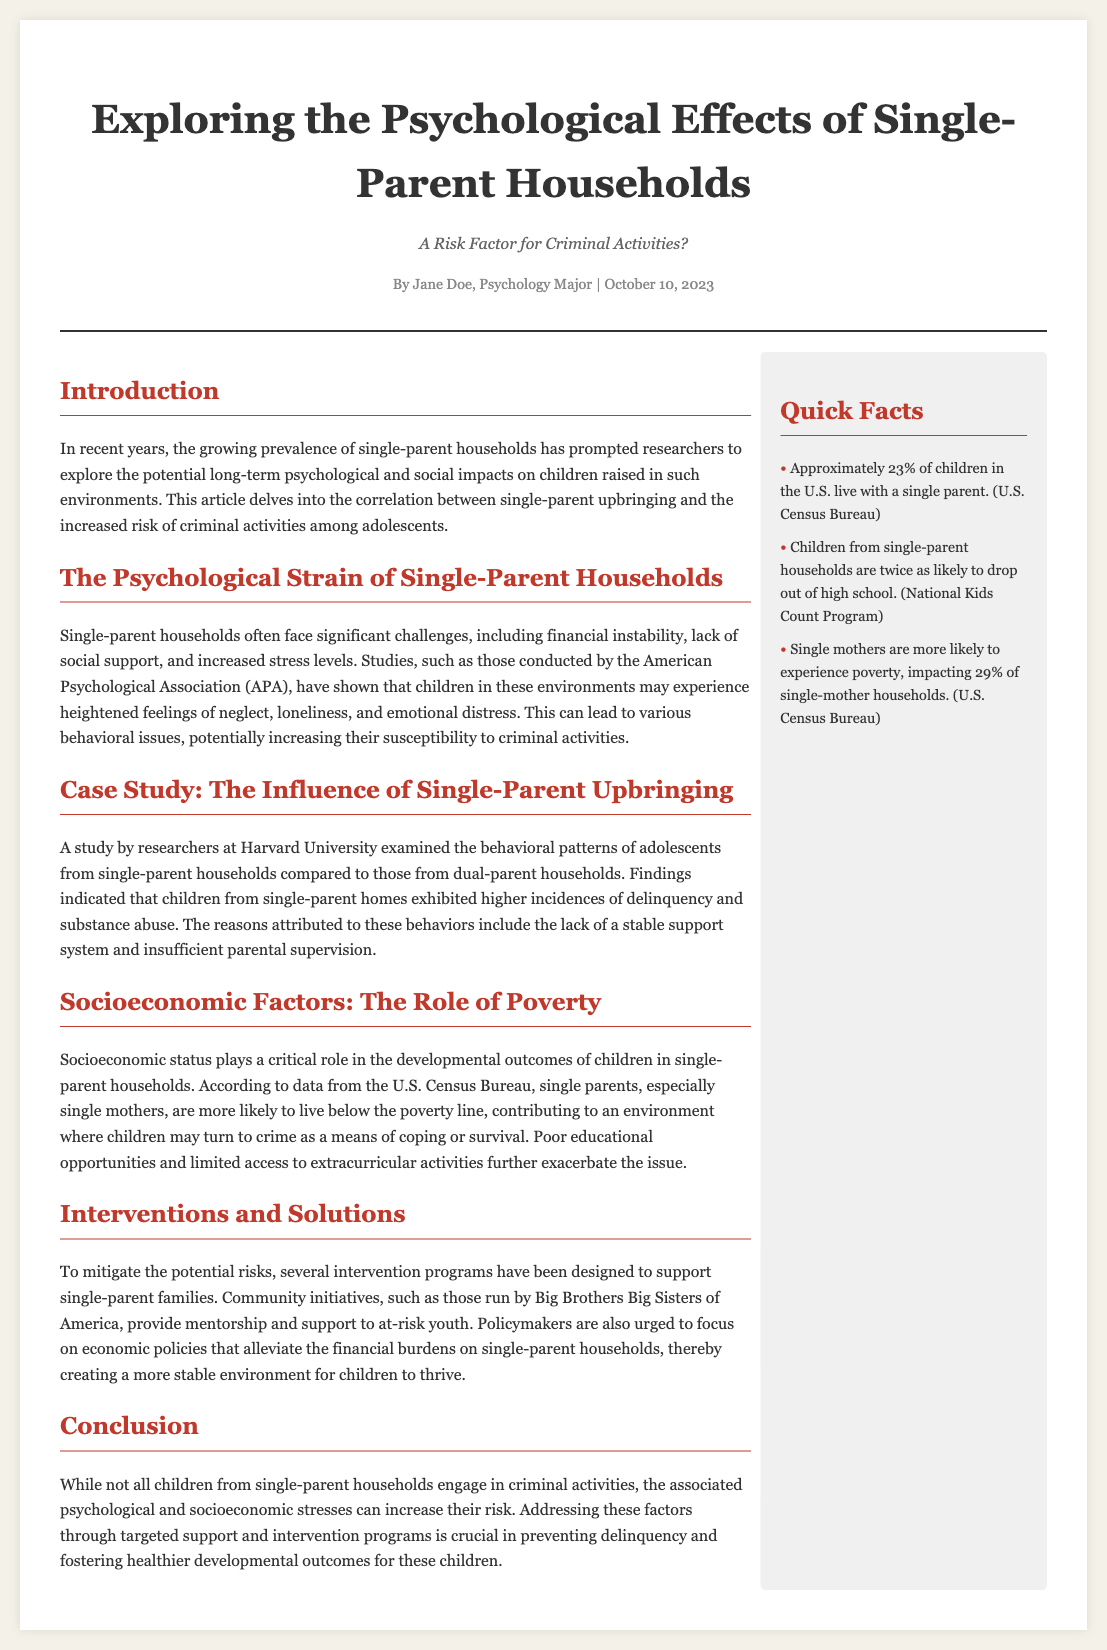what is the title of the article? The title is prominently displayed at the top of the document, indicating the primary focus of the article.
Answer: Exploring the Psychological Effects of Single-Parent Households who is the author of the article? The author's name is listed below the title and indicates the person responsible for the content.
Answer: Jane Doe what percentage of children in the U.S. live with a single parent? This statistic is provided as a quick fact in the aside section of the document.
Answer: Approximately 23% what major challenge do single-parent households often face? This challenge is mentioned in the section discussing the psychological strain on families.
Answer: Financial instability which university conducted the study mentioned in the case study? The specific university is mentioned within the case study section of the article.
Answer: Harvard University what is one potential intervention program for single-parent families mentioned? The article discusses various initiatives designed to support these families, highlighting one specifically.
Answer: Big Brothers Big Sisters of America how much higher are the chances of dropping out of high school for children from single-parent households? This information is provided as a statistic in the quick facts section of the article.
Answer: Twice as likely what is the publication date of the article? The date of publication is noted in the meta section of the document.
Answer: October 10, 2023 